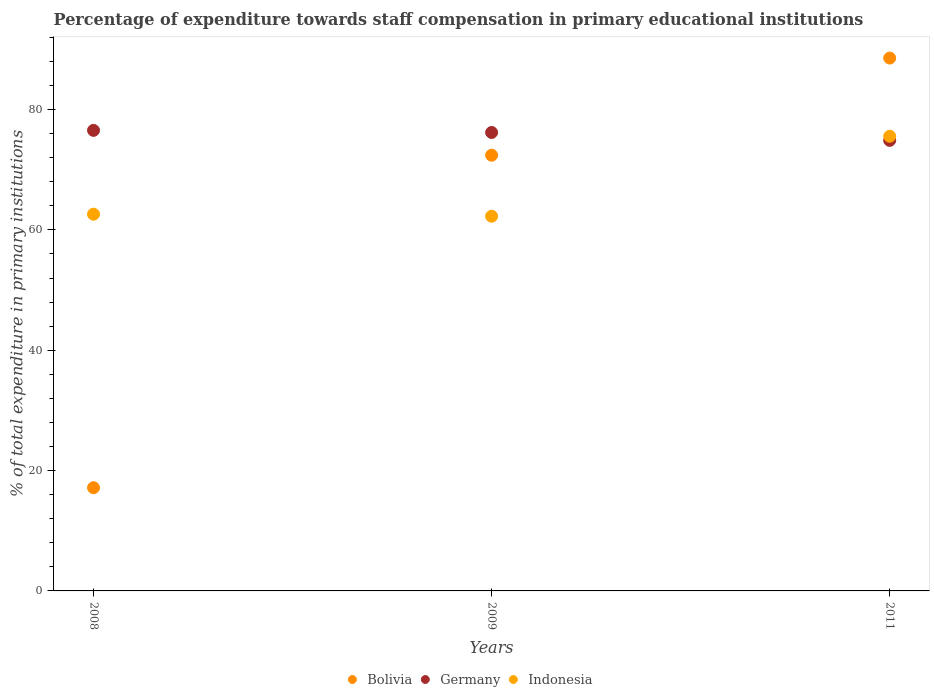How many different coloured dotlines are there?
Make the answer very short. 3. Is the number of dotlines equal to the number of legend labels?
Your answer should be very brief. Yes. What is the percentage of expenditure towards staff compensation in Bolivia in 2009?
Your response must be concise. 72.41. Across all years, what is the maximum percentage of expenditure towards staff compensation in Indonesia?
Make the answer very short. 75.56. Across all years, what is the minimum percentage of expenditure towards staff compensation in Bolivia?
Provide a succinct answer. 17.15. In which year was the percentage of expenditure towards staff compensation in Indonesia maximum?
Your answer should be compact. 2011. What is the total percentage of expenditure towards staff compensation in Indonesia in the graph?
Ensure brevity in your answer.  200.43. What is the difference between the percentage of expenditure towards staff compensation in Germany in 2008 and that in 2009?
Your answer should be very brief. 0.35. What is the difference between the percentage of expenditure towards staff compensation in Indonesia in 2011 and the percentage of expenditure towards staff compensation in Germany in 2008?
Keep it short and to the point. -0.98. What is the average percentage of expenditure towards staff compensation in Bolivia per year?
Your answer should be very brief. 59.37. In the year 2008, what is the difference between the percentage of expenditure towards staff compensation in Indonesia and percentage of expenditure towards staff compensation in Germany?
Your response must be concise. -13.93. In how many years, is the percentage of expenditure towards staff compensation in Bolivia greater than 80 %?
Offer a very short reply. 1. What is the ratio of the percentage of expenditure towards staff compensation in Germany in 2009 to that in 2011?
Keep it short and to the point. 1.02. Is the percentage of expenditure towards staff compensation in Bolivia in 2008 less than that in 2009?
Your answer should be very brief. Yes. Is the difference between the percentage of expenditure towards staff compensation in Indonesia in 2008 and 2011 greater than the difference between the percentage of expenditure towards staff compensation in Germany in 2008 and 2011?
Your answer should be compact. No. What is the difference between the highest and the second highest percentage of expenditure towards staff compensation in Indonesia?
Keep it short and to the point. 12.95. What is the difference between the highest and the lowest percentage of expenditure towards staff compensation in Bolivia?
Provide a succinct answer. 71.4. Is the percentage of expenditure towards staff compensation in Indonesia strictly greater than the percentage of expenditure towards staff compensation in Bolivia over the years?
Provide a succinct answer. No. Is the percentage of expenditure towards staff compensation in Bolivia strictly less than the percentage of expenditure towards staff compensation in Germany over the years?
Your response must be concise. No. Are the values on the major ticks of Y-axis written in scientific E-notation?
Your response must be concise. No. Does the graph contain grids?
Your answer should be compact. No. How are the legend labels stacked?
Offer a very short reply. Horizontal. What is the title of the graph?
Offer a terse response. Percentage of expenditure towards staff compensation in primary educational institutions. Does "Kosovo" appear as one of the legend labels in the graph?
Offer a very short reply. No. What is the label or title of the Y-axis?
Make the answer very short. % of total expenditure in primary institutions. What is the % of total expenditure in primary institutions of Bolivia in 2008?
Give a very brief answer. 17.15. What is the % of total expenditure in primary institutions in Germany in 2008?
Provide a succinct answer. 76.54. What is the % of total expenditure in primary institutions of Indonesia in 2008?
Make the answer very short. 62.61. What is the % of total expenditure in primary institutions in Bolivia in 2009?
Give a very brief answer. 72.41. What is the % of total expenditure in primary institutions of Germany in 2009?
Your answer should be very brief. 76.19. What is the % of total expenditure in primary institutions in Indonesia in 2009?
Your answer should be very brief. 62.27. What is the % of total expenditure in primary institutions in Bolivia in 2011?
Give a very brief answer. 88.55. What is the % of total expenditure in primary institutions of Germany in 2011?
Offer a terse response. 74.87. What is the % of total expenditure in primary institutions of Indonesia in 2011?
Your answer should be very brief. 75.56. Across all years, what is the maximum % of total expenditure in primary institutions of Bolivia?
Provide a short and direct response. 88.55. Across all years, what is the maximum % of total expenditure in primary institutions in Germany?
Provide a succinct answer. 76.54. Across all years, what is the maximum % of total expenditure in primary institutions in Indonesia?
Give a very brief answer. 75.56. Across all years, what is the minimum % of total expenditure in primary institutions in Bolivia?
Offer a terse response. 17.15. Across all years, what is the minimum % of total expenditure in primary institutions of Germany?
Ensure brevity in your answer.  74.87. Across all years, what is the minimum % of total expenditure in primary institutions of Indonesia?
Keep it short and to the point. 62.27. What is the total % of total expenditure in primary institutions in Bolivia in the graph?
Your response must be concise. 178.12. What is the total % of total expenditure in primary institutions in Germany in the graph?
Offer a very short reply. 227.6. What is the total % of total expenditure in primary institutions of Indonesia in the graph?
Provide a succinct answer. 200.43. What is the difference between the % of total expenditure in primary institutions of Bolivia in 2008 and that in 2009?
Provide a succinct answer. -55.26. What is the difference between the % of total expenditure in primary institutions of Germany in 2008 and that in 2009?
Give a very brief answer. 0.35. What is the difference between the % of total expenditure in primary institutions of Indonesia in 2008 and that in 2009?
Offer a terse response. 0.34. What is the difference between the % of total expenditure in primary institutions in Bolivia in 2008 and that in 2011?
Give a very brief answer. -71.4. What is the difference between the % of total expenditure in primary institutions in Germany in 2008 and that in 2011?
Your answer should be compact. 1.67. What is the difference between the % of total expenditure in primary institutions of Indonesia in 2008 and that in 2011?
Your answer should be compact. -12.95. What is the difference between the % of total expenditure in primary institutions in Bolivia in 2009 and that in 2011?
Keep it short and to the point. -16.14. What is the difference between the % of total expenditure in primary institutions in Germany in 2009 and that in 2011?
Your answer should be compact. 1.32. What is the difference between the % of total expenditure in primary institutions of Indonesia in 2009 and that in 2011?
Ensure brevity in your answer.  -13.29. What is the difference between the % of total expenditure in primary institutions in Bolivia in 2008 and the % of total expenditure in primary institutions in Germany in 2009?
Your answer should be very brief. -59.03. What is the difference between the % of total expenditure in primary institutions of Bolivia in 2008 and the % of total expenditure in primary institutions of Indonesia in 2009?
Keep it short and to the point. -45.11. What is the difference between the % of total expenditure in primary institutions of Germany in 2008 and the % of total expenditure in primary institutions of Indonesia in 2009?
Ensure brevity in your answer.  14.27. What is the difference between the % of total expenditure in primary institutions in Bolivia in 2008 and the % of total expenditure in primary institutions in Germany in 2011?
Offer a very short reply. -57.72. What is the difference between the % of total expenditure in primary institutions in Bolivia in 2008 and the % of total expenditure in primary institutions in Indonesia in 2011?
Keep it short and to the point. -58.4. What is the difference between the % of total expenditure in primary institutions in Germany in 2008 and the % of total expenditure in primary institutions in Indonesia in 2011?
Your answer should be compact. 0.98. What is the difference between the % of total expenditure in primary institutions of Bolivia in 2009 and the % of total expenditure in primary institutions of Germany in 2011?
Offer a very short reply. -2.46. What is the difference between the % of total expenditure in primary institutions in Bolivia in 2009 and the % of total expenditure in primary institutions in Indonesia in 2011?
Make the answer very short. -3.15. What is the difference between the % of total expenditure in primary institutions in Germany in 2009 and the % of total expenditure in primary institutions in Indonesia in 2011?
Provide a short and direct response. 0.63. What is the average % of total expenditure in primary institutions of Bolivia per year?
Give a very brief answer. 59.37. What is the average % of total expenditure in primary institutions of Germany per year?
Your answer should be very brief. 75.87. What is the average % of total expenditure in primary institutions of Indonesia per year?
Your response must be concise. 66.81. In the year 2008, what is the difference between the % of total expenditure in primary institutions in Bolivia and % of total expenditure in primary institutions in Germany?
Keep it short and to the point. -59.39. In the year 2008, what is the difference between the % of total expenditure in primary institutions in Bolivia and % of total expenditure in primary institutions in Indonesia?
Make the answer very short. -45.45. In the year 2008, what is the difference between the % of total expenditure in primary institutions in Germany and % of total expenditure in primary institutions in Indonesia?
Make the answer very short. 13.93. In the year 2009, what is the difference between the % of total expenditure in primary institutions in Bolivia and % of total expenditure in primary institutions in Germany?
Keep it short and to the point. -3.78. In the year 2009, what is the difference between the % of total expenditure in primary institutions of Bolivia and % of total expenditure in primary institutions of Indonesia?
Offer a very short reply. 10.14. In the year 2009, what is the difference between the % of total expenditure in primary institutions in Germany and % of total expenditure in primary institutions in Indonesia?
Your response must be concise. 13.92. In the year 2011, what is the difference between the % of total expenditure in primary institutions of Bolivia and % of total expenditure in primary institutions of Germany?
Ensure brevity in your answer.  13.68. In the year 2011, what is the difference between the % of total expenditure in primary institutions of Bolivia and % of total expenditure in primary institutions of Indonesia?
Provide a succinct answer. 13. In the year 2011, what is the difference between the % of total expenditure in primary institutions of Germany and % of total expenditure in primary institutions of Indonesia?
Give a very brief answer. -0.68. What is the ratio of the % of total expenditure in primary institutions of Bolivia in 2008 to that in 2009?
Offer a very short reply. 0.24. What is the ratio of the % of total expenditure in primary institutions of Germany in 2008 to that in 2009?
Give a very brief answer. 1. What is the ratio of the % of total expenditure in primary institutions in Bolivia in 2008 to that in 2011?
Ensure brevity in your answer.  0.19. What is the ratio of the % of total expenditure in primary institutions of Germany in 2008 to that in 2011?
Offer a very short reply. 1.02. What is the ratio of the % of total expenditure in primary institutions in Indonesia in 2008 to that in 2011?
Offer a very short reply. 0.83. What is the ratio of the % of total expenditure in primary institutions of Bolivia in 2009 to that in 2011?
Provide a short and direct response. 0.82. What is the ratio of the % of total expenditure in primary institutions in Germany in 2009 to that in 2011?
Make the answer very short. 1.02. What is the ratio of the % of total expenditure in primary institutions of Indonesia in 2009 to that in 2011?
Keep it short and to the point. 0.82. What is the difference between the highest and the second highest % of total expenditure in primary institutions of Bolivia?
Offer a terse response. 16.14. What is the difference between the highest and the second highest % of total expenditure in primary institutions of Germany?
Provide a succinct answer. 0.35. What is the difference between the highest and the second highest % of total expenditure in primary institutions in Indonesia?
Provide a succinct answer. 12.95. What is the difference between the highest and the lowest % of total expenditure in primary institutions in Bolivia?
Your answer should be very brief. 71.4. What is the difference between the highest and the lowest % of total expenditure in primary institutions in Germany?
Keep it short and to the point. 1.67. What is the difference between the highest and the lowest % of total expenditure in primary institutions in Indonesia?
Ensure brevity in your answer.  13.29. 